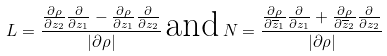Convert formula to latex. <formula><loc_0><loc_0><loc_500><loc_500>L = \frac { \frac { \partial \rho } { \partial z _ { 2 } } \frac { \partial } { \partial z _ { 1 } } - \frac { \partial \rho } { \partial z _ { 1 } } \frac { \partial } { \partial z _ { 2 } } } { | \partial \rho | } \, \text {and} \, N = \frac { \frac { \partial \rho } { \partial \overline { z } _ { 1 } } \frac { \partial } { \partial z _ { 1 } } + \frac { \partial \rho } { \partial \overline { z } _ { 2 } } \frac { \partial } { \partial z _ { 2 } } } { | \partial \rho | }</formula> 